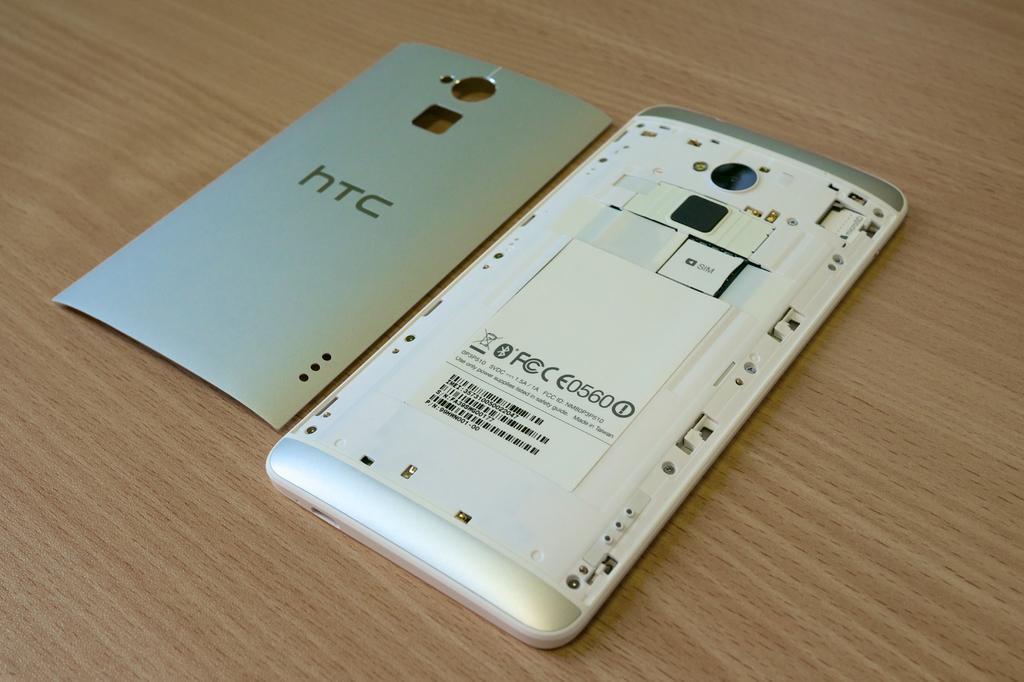Can you describe this image briefly? In this image there is a cell phone on the table. Beside there is a cover of the cell phone. 